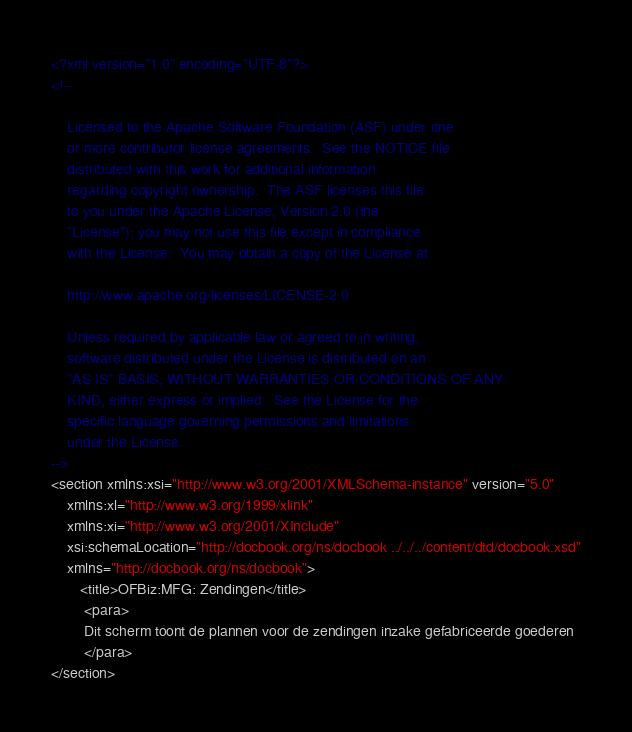<code> <loc_0><loc_0><loc_500><loc_500><_XML_><?xml version="1.0" encoding="UTF-8"?>
<!--

    Licensed to the Apache Software Foundation (ASF) under one
    or more contributor license agreements.  See the NOTICE file
    distributed with this work for additional information
    regarding copyright ownership.  The ASF licenses this file
    to you under the Apache License, Version 2.0 (the
    "License"); you may not use this file except in compliance
    with the License.  You may obtain a copy of the License at

    http://www.apache.org/licenses/LICENSE-2.0

    Unless required by applicable law or agreed to in writing,
    software distributed under the License is distributed on an
    "AS IS" BASIS, WITHOUT WARRANTIES OR CONDITIONS OF ANY
    KIND, either express or implied.  See the License for the
    specific language governing permissions and limitations
    under the License.
-->
<section xmlns:xsi="http://www.w3.org/2001/XMLSchema-instance" version="5.0" 
    xmlns:xl="http://www.w3.org/1999/xlink" 
    xmlns:xi="http://www.w3.org/2001/XInclude"
    xsi:schemaLocation="http://docbook.org/ns/docbook ../../../content/dtd/docbook.xsd"
    xmlns="http://docbook.org/ns/docbook">
       <title>OFBiz:MFG: Zendingen</title>
        <para>
        Dit scherm toont de plannen voor de zendingen inzake gefabriceerde goederen
        </para>
</section></code> 